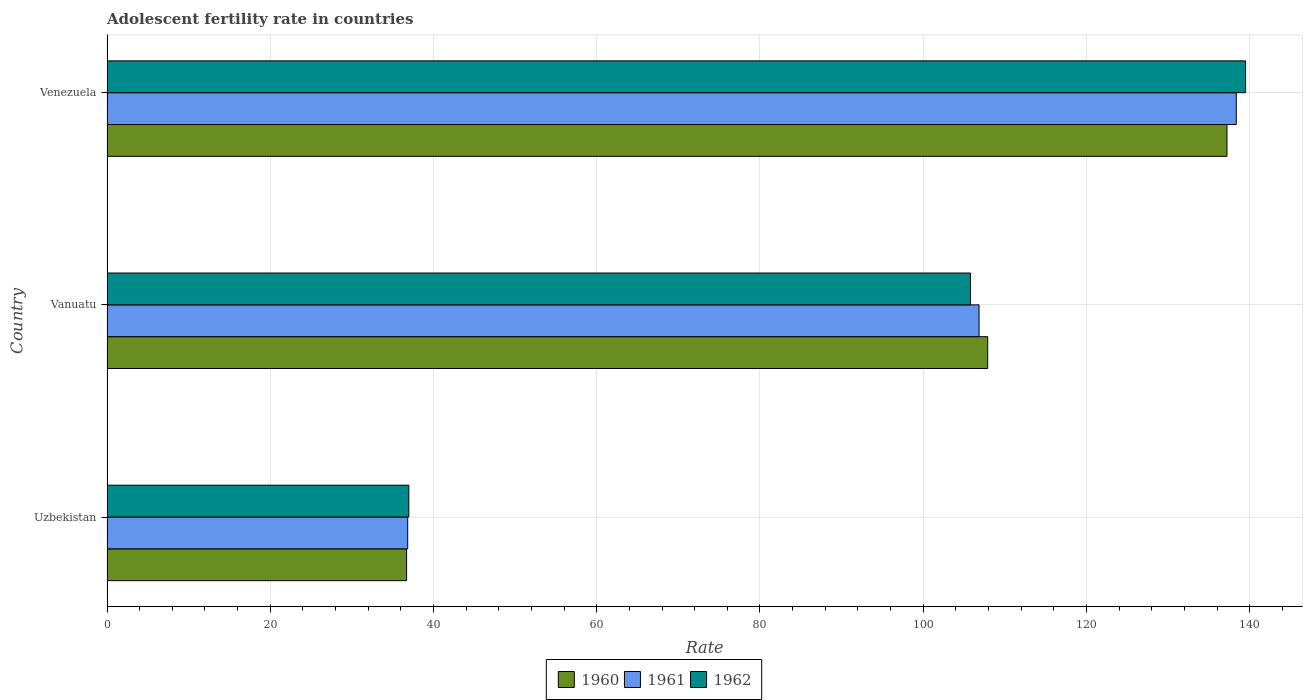How many different coloured bars are there?
Ensure brevity in your answer.  3. How many groups of bars are there?
Make the answer very short. 3. Are the number of bars on each tick of the Y-axis equal?
Ensure brevity in your answer.  Yes. How many bars are there on the 3rd tick from the top?
Provide a succinct answer. 3. How many bars are there on the 3rd tick from the bottom?
Offer a very short reply. 3. What is the label of the 2nd group of bars from the top?
Your answer should be very brief. Vanuatu. In how many cases, is the number of bars for a given country not equal to the number of legend labels?
Offer a terse response. 0. What is the adolescent fertility rate in 1960 in Vanuatu?
Your answer should be very brief. 107.9. Across all countries, what is the maximum adolescent fertility rate in 1962?
Give a very brief answer. 139.49. Across all countries, what is the minimum adolescent fertility rate in 1962?
Your response must be concise. 36.98. In which country was the adolescent fertility rate in 1960 maximum?
Offer a terse response. Venezuela. In which country was the adolescent fertility rate in 1962 minimum?
Keep it short and to the point. Uzbekistan. What is the total adolescent fertility rate in 1960 in the graph?
Your answer should be very brief. 281.81. What is the difference between the adolescent fertility rate in 1962 in Uzbekistan and that in Venezuela?
Your answer should be compact. -102.51. What is the difference between the adolescent fertility rate in 1961 in Uzbekistan and the adolescent fertility rate in 1960 in Vanuatu?
Give a very brief answer. -71.06. What is the average adolescent fertility rate in 1960 per country?
Keep it short and to the point. 93.94. What is the difference between the adolescent fertility rate in 1962 and adolescent fertility rate in 1961 in Uzbekistan?
Offer a terse response. 0.14. In how many countries, is the adolescent fertility rate in 1962 greater than 64 ?
Offer a terse response. 2. What is the ratio of the adolescent fertility rate in 1962 in Vanuatu to that in Venezuela?
Your response must be concise. 0.76. What is the difference between the highest and the second highest adolescent fertility rate in 1962?
Provide a succinct answer. 33.71. What is the difference between the highest and the lowest adolescent fertility rate in 1961?
Ensure brevity in your answer.  101.51. In how many countries, is the adolescent fertility rate in 1962 greater than the average adolescent fertility rate in 1962 taken over all countries?
Offer a terse response. 2. What does the 1st bar from the top in Venezuela represents?
Your answer should be very brief. 1962. How many countries are there in the graph?
Offer a terse response. 3. Does the graph contain grids?
Your answer should be compact. Yes. How are the legend labels stacked?
Keep it short and to the point. Horizontal. What is the title of the graph?
Offer a terse response. Adolescent fertility rate in countries. What is the label or title of the X-axis?
Offer a very short reply. Rate. What is the Rate in 1960 in Uzbekistan?
Offer a terse response. 36.7. What is the Rate of 1961 in Uzbekistan?
Offer a very short reply. 36.84. What is the Rate in 1962 in Uzbekistan?
Provide a short and direct response. 36.98. What is the Rate of 1960 in Vanuatu?
Ensure brevity in your answer.  107.9. What is the Rate of 1961 in Vanuatu?
Provide a short and direct response. 106.84. What is the Rate in 1962 in Vanuatu?
Your response must be concise. 105.78. What is the Rate of 1960 in Venezuela?
Ensure brevity in your answer.  137.21. What is the Rate in 1961 in Venezuela?
Give a very brief answer. 138.35. What is the Rate of 1962 in Venezuela?
Give a very brief answer. 139.49. Across all countries, what is the maximum Rate in 1960?
Keep it short and to the point. 137.21. Across all countries, what is the maximum Rate of 1961?
Your answer should be very brief. 138.35. Across all countries, what is the maximum Rate of 1962?
Your answer should be compact. 139.49. Across all countries, what is the minimum Rate in 1960?
Ensure brevity in your answer.  36.7. Across all countries, what is the minimum Rate of 1961?
Provide a short and direct response. 36.84. Across all countries, what is the minimum Rate in 1962?
Your answer should be very brief. 36.98. What is the total Rate of 1960 in the graph?
Your answer should be very brief. 281.81. What is the total Rate of 1961 in the graph?
Keep it short and to the point. 282.03. What is the total Rate in 1962 in the graph?
Offer a terse response. 282.25. What is the difference between the Rate of 1960 in Uzbekistan and that in Vanuatu?
Make the answer very short. -71.19. What is the difference between the Rate in 1961 in Uzbekistan and that in Vanuatu?
Make the answer very short. -70. What is the difference between the Rate of 1962 in Uzbekistan and that in Vanuatu?
Provide a succinct answer. -68.8. What is the difference between the Rate of 1960 in Uzbekistan and that in Venezuela?
Your answer should be compact. -100.51. What is the difference between the Rate of 1961 in Uzbekistan and that in Venezuela?
Your response must be concise. -101.51. What is the difference between the Rate of 1962 in Uzbekistan and that in Venezuela?
Keep it short and to the point. -102.51. What is the difference between the Rate of 1960 in Vanuatu and that in Venezuela?
Offer a very short reply. -29.32. What is the difference between the Rate of 1961 in Vanuatu and that in Venezuela?
Ensure brevity in your answer.  -31.51. What is the difference between the Rate in 1962 in Vanuatu and that in Venezuela?
Offer a terse response. -33.71. What is the difference between the Rate in 1960 in Uzbekistan and the Rate in 1961 in Vanuatu?
Offer a terse response. -70.14. What is the difference between the Rate in 1960 in Uzbekistan and the Rate in 1962 in Vanuatu?
Your answer should be very brief. -69.08. What is the difference between the Rate of 1961 in Uzbekistan and the Rate of 1962 in Vanuatu?
Provide a short and direct response. -68.94. What is the difference between the Rate of 1960 in Uzbekistan and the Rate of 1961 in Venezuela?
Offer a very short reply. -101.65. What is the difference between the Rate of 1960 in Uzbekistan and the Rate of 1962 in Venezuela?
Make the answer very short. -102.79. What is the difference between the Rate of 1961 in Uzbekistan and the Rate of 1962 in Venezuela?
Your answer should be compact. -102.65. What is the difference between the Rate of 1960 in Vanuatu and the Rate of 1961 in Venezuela?
Ensure brevity in your answer.  -30.45. What is the difference between the Rate in 1960 in Vanuatu and the Rate in 1962 in Venezuela?
Give a very brief answer. -31.59. What is the difference between the Rate in 1961 in Vanuatu and the Rate in 1962 in Venezuela?
Offer a terse response. -32.65. What is the average Rate in 1960 per country?
Ensure brevity in your answer.  93.94. What is the average Rate of 1961 per country?
Offer a terse response. 94.01. What is the average Rate in 1962 per country?
Provide a short and direct response. 94.08. What is the difference between the Rate in 1960 and Rate in 1961 in Uzbekistan?
Your answer should be compact. -0.14. What is the difference between the Rate of 1960 and Rate of 1962 in Uzbekistan?
Offer a terse response. -0.27. What is the difference between the Rate of 1961 and Rate of 1962 in Uzbekistan?
Offer a terse response. -0.14. What is the difference between the Rate in 1960 and Rate in 1961 in Vanuatu?
Your response must be concise. 1.06. What is the difference between the Rate of 1960 and Rate of 1962 in Vanuatu?
Provide a succinct answer. 2.12. What is the difference between the Rate in 1961 and Rate in 1962 in Vanuatu?
Make the answer very short. 1.06. What is the difference between the Rate of 1960 and Rate of 1961 in Venezuela?
Keep it short and to the point. -1.14. What is the difference between the Rate of 1960 and Rate of 1962 in Venezuela?
Provide a short and direct response. -2.28. What is the difference between the Rate of 1961 and Rate of 1962 in Venezuela?
Offer a very short reply. -1.14. What is the ratio of the Rate of 1960 in Uzbekistan to that in Vanuatu?
Provide a succinct answer. 0.34. What is the ratio of the Rate of 1961 in Uzbekistan to that in Vanuatu?
Your answer should be very brief. 0.34. What is the ratio of the Rate in 1962 in Uzbekistan to that in Vanuatu?
Offer a very short reply. 0.35. What is the ratio of the Rate in 1960 in Uzbekistan to that in Venezuela?
Your answer should be compact. 0.27. What is the ratio of the Rate of 1961 in Uzbekistan to that in Venezuela?
Your answer should be very brief. 0.27. What is the ratio of the Rate in 1962 in Uzbekistan to that in Venezuela?
Your answer should be compact. 0.27. What is the ratio of the Rate in 1960 in Vanuatu to that in Venezuela?
Keep it short and to the point. 0.79. What is the ratio of the Rate in 1961 in Vanuatu to that in Venezuela?
Keep it short and to the point. 0.77. What is the ratio of the Rate in 1962 in Vanuatu to that in Venezuela?
Provide a short and direct response. 0.76. What is the difference between the highest and the second highest Rate in 1960?
Offer a terse response. 29.32. What is the difference between the highest and the second highest Rate of 1961?
Provide a succinct answer. 31.51. What is the difference between the highest and the second highest Rate in 1962?
Your answer should be compact. 33.71. What is the difference between the highest and the lowest Rate in 1960?
Your answer should be very brief. 100.51. What is the difference between the highest and the lowest Rate in 1961?
Your answer should be compact. 101.51. What is the difference between the highest and the lowest Rate in 1962?
Your response must be concise. 102.51. 